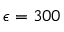Convert formula to latex. <formula><loc_0><loc_0><loc_500><loc_500>\epsilon = 3 0 0</formula> 